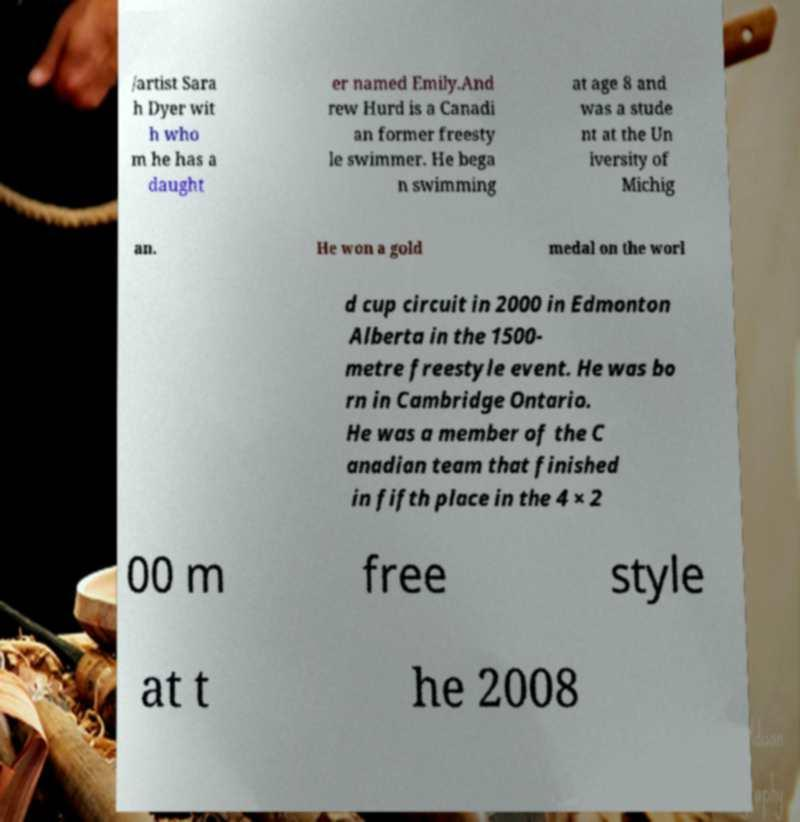For documentation purposes, I need the text within this image transcribed. Could you provide that? /artist Sara h Dyer wit h who m he has a daught er named Emily.And rew Hurd is a Canadi an former freesty le swimmer. He bega n swimming at age 8 and was a stude nt at the Un iversity of Michig an. He won a gold medal on the worl d cup circuit in 2000 in Edmonton Alberta in the 1500- metre freestyle event. He was bo rn in Cambridge Ontario. He was a member of the C anadian team that finished in fifth place in the 4 × 2 00 m free style at t he 2008 